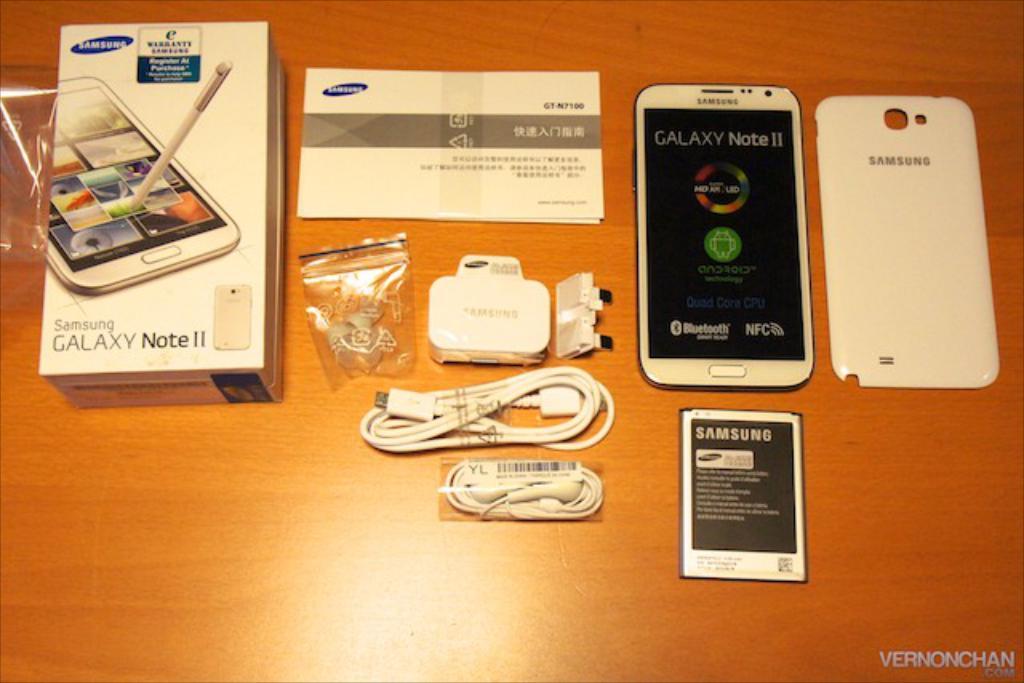What model of samsung is this phone?
Make the answer very short. Galaxy note ii. What operating system does this samsung run?
Provide a succinct answer. Unanswerable. 